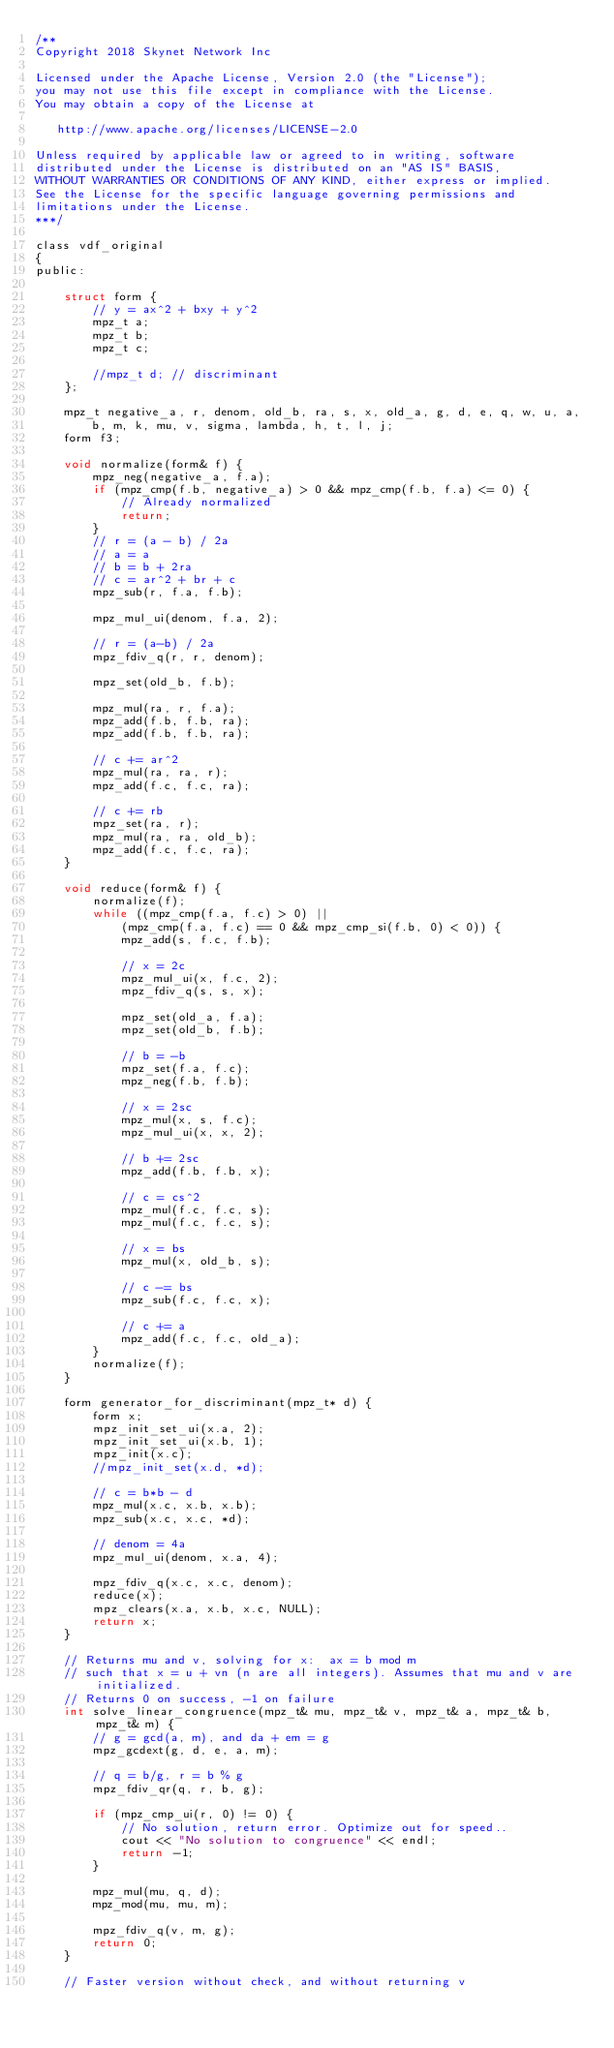Convert code to text. <code><loc_0><loc_0><loc_500><loc_500><_C_>/**
Copyright 2018 Skynet Network Inc

Licensed under the Apache License, Version 2.0 (the "License");
you may not use this file except in compliance with the License.
You may obtain a copy of the License at

   http://www.apache.org/licenses/LICENSE-2.0

Unless required by applicable law or agreed to in writing, software
distributed under the License is distributed on an "AS IS" BASIS,
WITHOUT WARRANTIES OR CONDITIONS OF ANY KIND, either express or implied.
See the License for the specific language governing permissions and
limitations under the License.
***/

class vdf_original
{
public:
    
    struct form {
        // y = ax^2 + bxy + y^2
        mpz_t a;
        mpz_t b;
        mpz_t c;

        //mpz_t d; // discriminant
    };

    mpz_t negative_a, r, denom, old_b, ra, s, x, old_a, g, d, e, q, w, u, a,
        b, m, k, mu, v, sigma, lambda, h, t, l, j;
    form f3;

    void normalize(form& f) {
        mpz_neg(negative_a, f.a);
        if (mpz_cmp(f.b, negative_a) > 0 && mpz_cmp(f.b, f.a) <= 0) {
            // Already normalized
            return;
        }
        // r = (a - b) / 2a
        // a = a
        // b = b + 2ra
        // c = ar^2 + br + c
        mpz_sub(r, f.a, f.b);

        mpz_mul_ui(denom, f.a, 2);

        // r = (a-b) / 2a
        mpz_fdiv_q(r, r, denom);

        mpz_set(old_b, f.b);

        mpz_mul(ra, r, f.a);
        mpz_add(f.b, f.b, ra);
        mpz_add(f.b, f.b, ra);

        // c += ar^2
        mpz_mul(ra, ra, r);
        mpz_add(f.c, f.c, ra);

        // c += rb
        mpz_set(ra, r);
        mpz_mul(ra, ra, old_b);
        mpz_add(f.c, f.c, ra);
    }

    void reduce(form& f) {
        normalize(f);
        while ((mpz_cmp(f.a, f.c) > 0) ||
            (mpz_cmp(f.a, f.c) == 0 && mpz_cmp_si(f.b, 0) < 0)) {
            mpz_add(s, f.c, f.b);

            // x = 2c
            mpz_mul_ui(x, f.c, 2);
            mpz_fdiv_q(s, s, x);

            mpz_set(old_a, f.a);
            mpz_set(old_b, f.b);

            // b = -b
            mpz_set(f.a, f.c);
            mpz_neg(f.b, f.b);

            // x = 2sc
            mpz_mul(x, s, f.c);
            mpz_mul_ui(x, x, 2);

            // b += 2sc
            mpz_add(f.b, f.b, x);

            // c = cs^2
            mpz_mul(f.c, f.c, s);
            mpz_mul(f.c, f.c, s);

            // x = bs
            mpz_mul(x, old_b, s);

            // c -= bs
            mpz_sub(f.c, f.c, x);

            // c += a
            mpz_add(f.c, f.c, old_a);
        }
        normalize(f);
    }

    form generator_for_discriminant(mpz_t* d) {
        form x;
        mpz_init_set_ui(x.a, 2);
        mpz_init_set_ui(x.b, 1);
        mpz_init(x.c);
        //mpz_init_set(x.d, *d);

        // c = b*b - d
        mpz_mul(x.c, x.b, x.b);
        mpz_sub(x.c, x.c, *d);

        // denom = 4a
        mpz_mul_ui(denom, x.a, 4);

        mpz_fdiv_q(x.c, x.c, denom);
        reduce(x);
        mpz_clears(x.a, x.b, x.c, NULL);
        return x;
    }

    // Returns mu and v, solving for x:  ax = b mod m
    // such that x = u + vn (n are all integers). Assumes that mu and v are initialized.
    // Returns 0 on success, -1 on failure
    int solve_linear_congruence(mpz_t& mu, mpz_t& v, mpz_t& a, mpz_t& b, mpz_t& m) {
        // g = gcd(a, m), and da + em = g
        mpz_gcdext(g, d, e, a, m);

        // q = b/g, r = b % g
        mpz_fdiv_qr(q, r, b, g);

        if (mpz_cmp_ui(r, 0) != 0) {
            // No solution, return error. Optimize out for speed..
            cout << "No solution to congruence" << endl;
            return -1;
        }

        mpz_mul(mu, q, d);
        mpz_mod(mu, mu, m);

        mpz_fdiv_q(v, m, g);
        return 0;
    }

    // Faster version without check, and without returning v</code> 